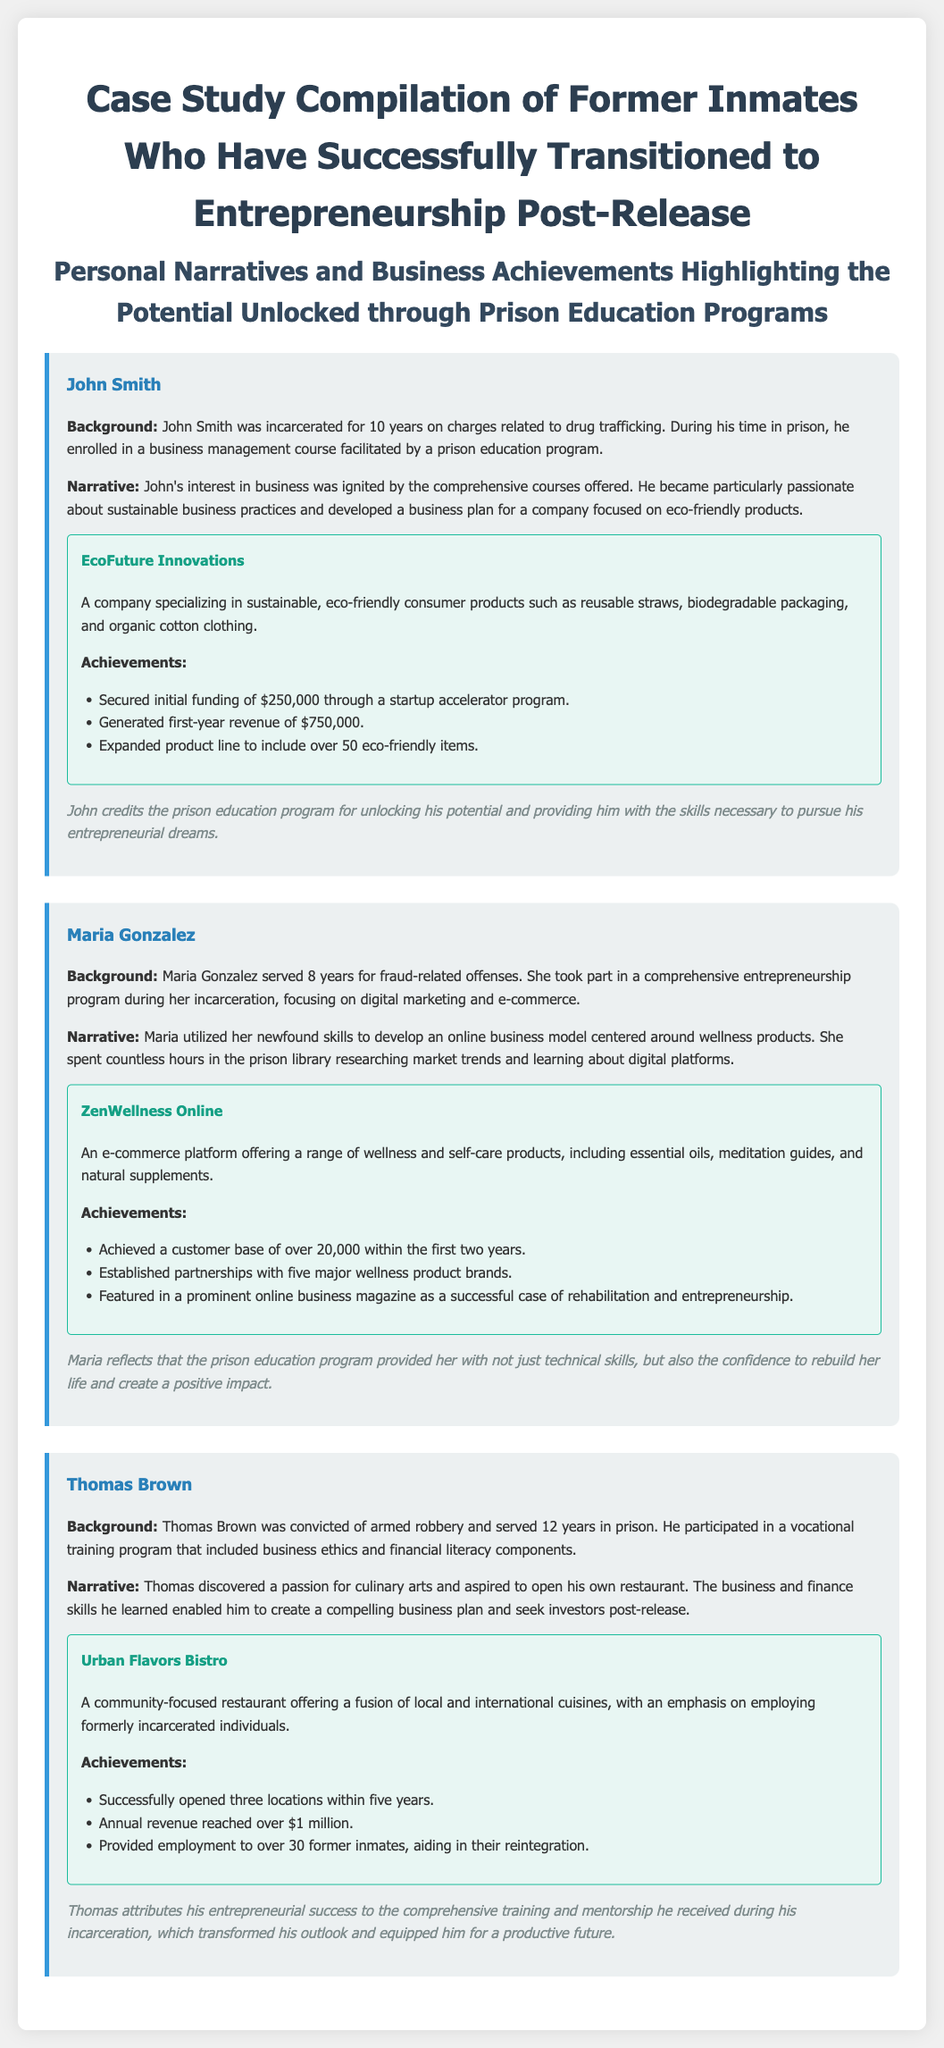What is the name of the first case study subject? The document introduces the first subject as John Smith.
Answer: John Smith How many years did Maria Gonzalez serve in prison? According to the background information, Maria Gonzalez served 8 years.
Answer: 8 years What is the name of Thomas Brown’s restaurant? The name of Thomas Brown's restaurant is provided as Urban Flavors Bistro.
Answer: Urban Flavors Bistro How much initial funding did John Smith secure? The document states that John Smith secured initial funding of $250,000.
Answer: $250,000 How many wellness product brands did Maria establish partnerships with? The document mentions that Maria established partnerships with five major wellness product brands.
Answer: Five What was the annual revenue of Urban Flavors Bistro? It is noted that Urban Flavors Bistro reached an annual revenue of over $1 million.
Answer: Over $1 million What type of products does EcoFuture Innovations specialize in? According to the document, EcoFuture Innovations specializes in sustainable, eco-friendly consumer products.
Answer: Sustainable, eco-friendly consumer products How many employees has Urban Flavors Bistro provided jobs to? The achievements section states that Urban Flavors Bistro has provided employment to over 30 former inmates.
Answer: Over 30 What did John Smith credit for unlocking his potential? John credits the prison education program for unlocking his potential.
Answer: Prison education program 